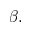Convert formula to latex. <formula><loc_0><loc_0><loc_500><loc_500>\beta .</formula> 